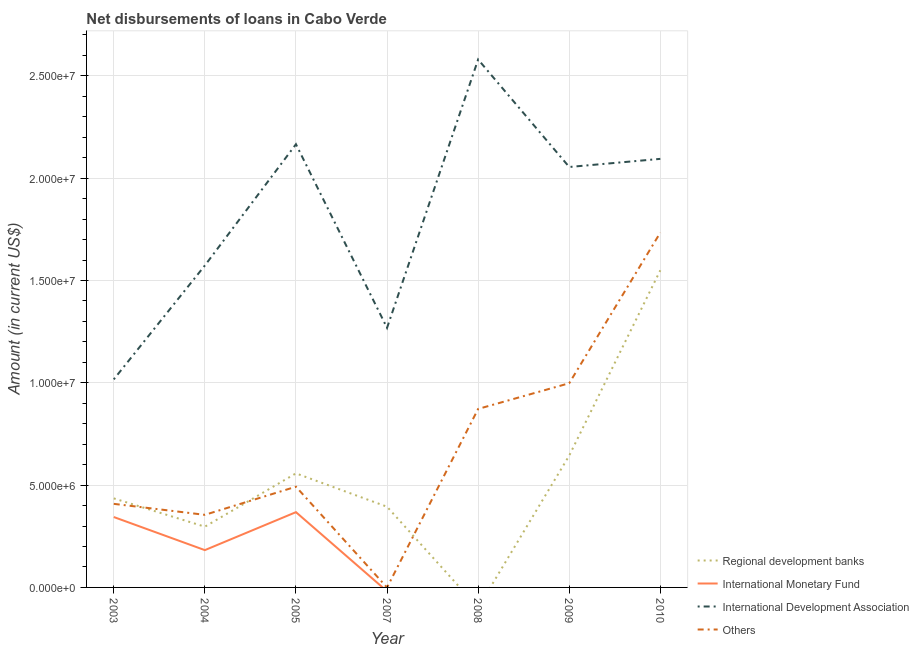How many different coloured lines are there?
Provide a short and direct response. 4. Does the line corresponding to amount of loan disimbursed by international development association intersect with the line corresponding to amount of loan disimbursed by regional development banks?
Provide a short and direct response. No. Is the number of lines equal to the number of legend labels?
Give a very brief answer. No. What is the amount of loan disimbursed by regional development banks in 2004?
Your answer should be compact. 2.97e+06. Across all years, what is the maximum amount of loan disimbursed by international development association?
Your answer should be very brief. 2.58e+07. Across all years, what is the minimum amount of loan disimbursed by international monetary fund?
Ensure brevity in your answer.  0. What is the total amount of loan disimbursed by international development association in the graph?
Offer a terse response. 1.28e+08. What is the difference between the amount of loan disimbursed by regional development banks in 2005 and that in 2007?
Make the answer very short. 1.63e+06. What is the difference between the amount of loan disimbursed by international monetary fund in 2004 and the amount of loan disimbursed by international development association in 2009?
Offer a terse response. -1.87e+07. What is the average amount of loan disimbursed by other organisations per year?
Make the answer very short. 6.94e+06. In the year 2003, what is the difference between the amount of loan disimbursed by international development association and amount of loan disimbursed by international monetary fund?
Give a very brief answer. 6.73e+06. In how many years, is the amount of loan disimbursed by international development association greater than 23000000 US$?
Make the answer very short. 1. What is the ratio of the amount of loan disimbursed by regional development banks in 2004 to that in 2005?
Make the answer very short. 0.53. Is the amount of loan disimbursed by regional development banks in 2005 less than that in 2009?
Provide a succinct answer. Yes. What is the difference between the highest and the second highest amount of loan disimbursed by regional development banks?
Your answer should be very brief. 9.06e+06. What is the difference between the highest and the lowest amount of loan disimbursed by international monetary fund?
Your response must be concise. 3.68e+06. Is the sum of the amount of loan disimbursed by regional development banks in 2004 and 2009 greater than the maximum amount of loan disimbursed by international development association across all years?
Your answer should be compact. No. Is it the case that in every year, the sum of the amount of loan disimbursed by regional development banks and amount of loan disimbursed by international monetary fund is greater than the sum of amount of loan disimbursed by international development association and amount of loan disimbursed by other organisations?
Provide a succinct answer. No. Is it the case that in every year, the sum of the amount of loan disimbursed by regional development banks and amount of loan disimbursed by international monetary fund is greater than the amount of loan disimbursed by international development association?
Offer a very short reply. No. Does the graph contain grids?
Offer a very short reply. Yes. Where does the legend appear in the graph?
Provide a succinct answer. Bottom right. How are the legend labels stacked?
Offer a very short reply. Vertical. What is the title of the graph?
Your answer should be very brief. Net disbursements of loans in Cabo Verde. What is the label or title of the X-axis?
Your response must be concise. Year. What is the Amount (in current US$) of Regional development banks in 2003?
Your answer should be very brief. 4.35e+06. What is the Amount (in current US$) of International Monetary Fund in 2003?
Your answer should be compact. 3.44e+06. What is the Amount (in current US$) of International Development Association in 2003?
Make the answer very short. 1.02e+07. What is the Amount (in current US$) in Others in 2003?
Offer a very short reply. 4.08e+06. What is the Amount (in current US$) of Regional development banks in 2004?
Provide a short and direct response. 2.97e+06. What is the Amount (in current US$) of International Monetary Fund in 2004?
Offer a very short reply. 1.82e+06. What is the Amount (in current US$) of International Development Association in 2004?
Your response must be concise. 1.57e+07. What is the Amount (in current US$) in Others in 2004?
Keep it short and to the point. 3.55e+06. What is the Amount (in current US$) of Regional development banks in 2005?
Make the answer very short. 5.58e+06. What is the Amount (in current US$) of International Monetary Fund in 2005?
Provide a short and direct response. 3.68e+06. What is the Amount (in current US$) of International Development Association in 2005?
Provide a succinct answer. 2.17e+07. What is the Amount (in current US$) in Others in 2005?
Give a very brief answer. 4.92e+06. What is the Amount (in current US$) in Regional development banks in 2007?
Give a very brief answer. 3.94e+06. What is the Amount (in current US$) in International Development Association in 2007?
Your response must be concise. 1.27e+07. What is the Amount (in current US$) in Regional development banks in 2008?
Keep it short and to the point. 0. What is the Amount (in current US$) in International Development Association in 2008?
Your response must be concise. 2.58e+07. What is the Amount (in current US$) in Others in 2008?
Keep it short and to the point. 8.72e+06. What is the Amount (in current US$) of Regional development banks in 2009?
Provide a short and direct response. 6.44e+06. What is the Amount (in current US$) of International Monetary Fund in 2009?
Give a very brief answer. 0. What is the Amount (in current US$) of International Development Association in 2009?
Ensure brevity in your answer.  2.05e+07. What is the Amount (in current US$) of Others in 2009?
Offer a very short reply. 9.98e+06. What is the Amount (in current US$) of Regional development banks in 2010?
Your answer should be compact. 1.55e+07. What is the Amount (in current US$) of International Development Association in 2010?
Offer a very short reply. 2.09e+07. What is the Amount (in current US$) of Others in 2010?
Make the answer very short. 1.73e+07. Across all years, what is the maximum Amount (in current US$) in Regional development banks?
Your answer should be very brief. 1.55e+07. Across all years, what is the maximum Amount (in current US$) in International Monetary Fund?
Provide a succinct answer. 3.68e+06. Across all years, what is the maximum Amount (in current US$) in International Development Association?
Keep it short and to the point. 2.58e+07. Across all years, what is the maximum Amount (in current US$) of Others?
Your response must be concise. 1.73e+07. Across all years, what is the minimum Amount (in current US$) of International Monetary Fund?
Provide a succinct answer. 0. Across all years, what is the minimum Amount (in current US$) in International Development Association?
Provide a succinct answer. 1.02e+07. What is the total Amount (in current US$) of Regional development banks in the graph?
Your answer should be compact. 3.88e+07. What is the total Amount (in current US$) in International Monetary Fund in the graph?
Make the answer very short. 8.94e+06. What is the total Amount (in current US$) of International Development Association in the graph?
Offer a very short reply. 1.28e+08. What is the total Amount (in current US$) in Others in the graph?
Keep it short and to the point. 4.86e+07. What is the difference between the Amount (in current US$) in Regional development banks in 2003 and that in 2004?
Give a very brief answer. 1.38e+06. What is the difference between the Amount (in current US$) of International Monetary Fund in 2003 and that in 2004?
Provide a short and direct response. 1.62e+06. What is the difference between the Amount (in current US$) of International Development Association in 2003 and that in 2004?
Your answer should be compact. -5.57e+06. What is the difference between the Amount (in current US$) of Others in 2003 and that in 2004?
Provide a succinct answer. 5.37e+05. What is the difference between the Amount (in current US$) in Regional development banks in 2003 and that in 2005?
Offer a very short reply. -1.22e+06. What is the difference between the Amount (in current US$) of International Monetary Fund in 2003 and that in 2005?
Your answer should be very brief. -2.38e+05. What is the difference between the Amount (in current US$) in International Development Association in 2003 and that in 2005?
Offer a very short reply. -1.15e+07. What is the difference between the Amount (in current US$) of Others in 2003 and that in 2005?
Provide a short and direct response. -8.38e+05. What is the difference between the Amount (in current US$) of Regional development banks in 2003 and that in 2007?
Your answer should be very brief. 4.08e+05. What is the difference between the Amount (in current US$) in International Development Association in 2003 and that in 2007?
Your answer should be compact. -2.52e+06. What is the difference between the Amount (in current US$) of International Development Association in 2003 and that in 2008?
Offer a terse response. -1.56e+07. What is the difference between the Amount (in current US$) in Others in 2003 and that in 2008?
Make the answer very short. -4.64e+06. What is the difference between the Amount (in current US$) of Regional development banks in 2003 and that in 2009?
Provide a succinct answer. -2.09e+06. What is the difference between the Amount (in current US$) of International Development Association in 2003 and that in 2009?
Offer a terse response. -1.04e+07. What is the difference between the Amount (in current US$) in Others in 2003 and that in 2009?
Your answer should be compact. -5.90e+06. What is the difference between the Amount (in current US$) in Regional development banks in 2003 and that in 2010?
Make the answer very short. -1.11e+07. What is the difference between the Amount (in current US$) of International Development Association in 2003 and that in 2010?
Your response must be concise. -1.08e+07. What is the difference between the Amount (in current US$) of Others in 2003 and that in 2010?
Give a very brief answer. -1.33e+07. What is the difference between the Amount (in current US$) of Regional development banks in 2004 and that in 2005?
Offer a very short reply. -2.61e+06. What is the difference between the Amount (in current US$) of International Monetary Fund in 2004 and that in 2005?
Your answer should be very brief. -1.86e+06. What is the difference between the Amount (in current US$) of International Development Association in 2004 and that in 2005?
Keep it short and to the point. -5.93e+06. What is the difference between the Amount (in current US$) in Others in 2004 and that in 2005?
Your answer should be very brief. -1.38e+06. What is the difference between the Amount (in current US$) in Regional development banks in 2004 and that in 2007?
Give a very brief answer. -9.76e+05. What is the difference between the Amount (in current US$) in International Development Association in 2004 and that in 2007?
Provide a succinct answer. 3.05e+06. What is the difference between the Amount (in current US$) in International Development Association in 2004 and that in 2008?
Give a very brief answer. -1.01e+07. What is the difference between the Amount (in current US$) in Others in 2004 and that in 2008?
Ensure brevity in your answer.  -5.18e+06. What is the difference between the Amount (in current US$) of Regional development banks in 2004 and that in 2009?
Provide a short and direct response. -3.48e+06. What is the difference between the Amount (in current US$) in International Development Association in 2004 and that in 2009?
Provide a succinct answer. -4.82e+06. What is the difference between the Amount (in current US$) in Others in 2004 and that in 2009?
Your response must be concise. -6.43e+06. What is the difference between the Amount (in current US$) of Regional development banks in 2004 and that in 2010?
Keep it short and to the point. -1.25e+07. What is the difference between the Amount (in current US$) in International Development Association in 2004 and that in 2010?
Your response must be concise. -5.21e+06. What is the difference between the Amount (in current US$) in Others in 2004 and that in 2010?
Offer a very short reply. -1.38e+07. What is the difference between the Amount (in current US$) of Regional development banks in 2005 and that in 2007?
Ensure brevity in your answer.  1.63e+06. What is the difference between the Amount (in current US$) in International Development Association in 2005 and that in 2007?
Your answer should be very brief. 8.97e+06. What is the difference between the Amount (in current US$) of International Development Association in 2005 and that in 2008?
Your answer should be very brief. -4.14e+06. What is the difference between the Amount (in current US$) in Others in 2005 and that in 2008?
Your answer should be compact. -3.80e+06. What is the difference between the Amount (in current US$) of Regional development banks in 2005 and that in 2009?
Your answer should be compact. -8.69e+05. What is the difference between the Amount (in current US$) in International Development Association in 2005 and that in 2009?
Ensure brevity in your answer.  1.11e+06. What is the difference between the Amount (in current US$) of Others in 2005 and that in 2009?
Keep it short and to the point. -5.06e+06. What is the difference between the Amount (in current US$) in Regional development banks in 2005 and that in 2010?
Your answer should be very brief. -9.93e+06. What is the difference between the Amount (in current US$) in International Development Association in 2005 and that in 2010?
Provide a short and direct response. 7.15e+05. What is the difference between the Amount (in current US$) of Others in 2005 and that in 2010?
Make the answer very short. -1.24e+07. What is the difference between the Amount (in current US$) of International Development Association in 2007 and that in 2008?
Give a very brief answer. -1.31e+07. What is the difference between the Amount (in current US$) of Regional development banks in 2007 and that in 2009?
Provide a short and direct response. -2.50e+06. What is the difference between the Amount (in current US$) of International Development Association in 2007 and that in 2009?
Keep it short and to the point. -7.86e+06. What is the difference between the Amount (in current US$) of Regional development banks in 2007 and that in 2010?
Provide a short and direct response. -1.16e+07. What is the difference between the Amount (in current US$) in International Development Association in 2007 and that in 2010?
Your answer should be very brief. -8.26e+06. What is the difference between the Amount (in current US$) in International Development Association in 2008 and that in 2009?
Ensure brevity in your answer.  5.25e+06. What is the difference between the Amount (in current US$) of Others in 2008 and that in 2009?
Offer a terse response. -1.26e+06. What is the difference between the Amount (in current US$) in International Development Association in 2008 and that in 2010?
Ensure brevity in your answer.  4.86e+06. What is the difference between the Amount (in current US$) of Others in 2008 and that in 2010?
Offer a very short reply. -8.62e+06. What is the difference between the Amount (in current US$) in Regional development banks in 2009 and that in 2010?
Keep it short and to the point. -9.06e+06. What is the difference between the Amount (in current US$) in International Development Association in 2009 and that in 2010?
Give a very brief answer. -3.97e+05. What is the difference between the Amount (in current US$) in Others in 2009 and that in 2010?
Offer a terse response. -7.36e+06. What is the difference between the Amount (in current US$) of Regional development banks in 2003 and the Amount (in current US$) of International Monetary Fund in 2004?
Your response must be concise. 2.53e+06. What is the difference between the Amount (in current US$) in Regional development banks in 2003 and the Amount (in current US$) in International Development Association in 2004?
Your response must be concise. -1.14e+07. What is the difference between the Amount (in current US$) of Regional development banks in 2003 and the Amount (in current US$) of Others in 2004?
Ensure brevity in your answer.  8.04e+05. What is the difference between the Amount (in current US$) in International Monetary Fund in 2003 and the Amount (in current US$) in International Development Association in 2004?
Provide a short and direct response. -1.23e+07. What is the difference between the Amount (in current US$) of International Monetary Fund in 2003 and the Amount (in current US$) of Others in 2004?
Keep it short and to the point. -1.07e+05. What is the difference between the Amount (in current US$) of International Development Association in 2003 and the Amount (in current US$) of Others in 2004?
Your response must be concise. 6.62e+06. What is the difference between the Amount (in current US$) of Regional development banks in 2003 and the Amount (in current US$) of International Monetary Fund in 2005?
Your response must be concise. 6.73e+05. What is the difference between the Amount (in current US$) in Regional development banks in 2003 and the Amount (in current US$) in International Development Association in 2005?
Ensure brevity in your answer.  -1.73e+07. What is the difference between the Amount (in current US$) in Regional development banks in 2003 and the Amount (in current US$) in Others in 2005?
Your answer should be very brief. -5.71e+05. What is the difference between the Amount (in current US$) of International Monetary Fund in 2003 and the Amount (in current US$) of International Development Association in 2005?
Your answer should be compact. -1.82e+07. What is the difference between the Amount (in current US$) in International Monetary Fund in 2003 and the Amount (in current US$) in Others in 2005?
Your response must be concise. -1.48e+06. What is the difference between the Amount (in current US$) of International Development Association in 2003 and the Amount (in current US$) of Others in 2005?
Provide a succinct answer. 5.24e+06. What is the difference between the Amount (in current US$) of Regional development banks in 2003 and the Amount (in current US$) of International Development Association in 2007?
Provide a short and direct response. -8.34e+06. What is the difference between the Amount (in current US$) of International Monetary Fund in 2003 and the Amount (in current US$) of International Development Association in 2007?
Offer a very short reply. -9.25e+06. What is the difference between the Amount (in current US$) in Regional development banks in 2003 and the Amount (in current US$) in International Development Association in 2008?
Offer a terse response. -2.14e+07. What is the difference between the Amount (in current US$) in Regional development banks in 2003 and the Amount (in current US$) in Others in 2008?
Offer a very short reply. -4.37e+06. What is the difference between the Amount (in current US$) in International Monetary Fund in 2003 and the Amount (in current US$) in International Development Association in 2008?
Your answer should be compact. -2.24e+07. What is the difference between the Amount (in current US$) in International Monetary Fund in 2003 and the Amount (in current US$) in Others in 2008?
Keep it short and to the point. -5.28e+06. What is the difference between the Amount (in current US$) in International Development Association in 2003 and the Amount (in current US$) in Others in 2008?
Give a very brief answer. 1.44e+06. What is the difference between the Amount (in current US$) in Regional development banks in 2003 and the Amount (in current US$) in International Development Association in 2009?
Make the answer very short. -1.62e+07. What is the difference between the Amount (in current US$) of Regional development banks in 2003 and the Amount (in current US$) of Others in 2009?
Your response must be concise. -5.63e+06. What is the difference between the Amount (in current US$) of International Monetary Fund in 2003 and the Amount (in current US$) of International Development Association in 2009?
Provide a short and direct response. -1.71e+07. What is the difference between the Amount (in current US$) in International Monetary Fund in 2003 and the Amount (in current US$) in Others in 2009?
Make the answer very short. -6.54e+06. What is the difference between the Amount (in current US$) of International Development Association in 2003 and the Amount (in current US$) of Others in 2009?
Offer a very short reply. 1.88e+05. What is the difference between the Amount (in current US$) in Regional development banks in 2003 and the Amount (in current US$) in International Development Association in 2010?
Your answer should be compact. -1.66e+07. What is the difference between the Amount (in current US$) of Regional development banks in 2003 and the Amount (in current US$) of Others in 2010?
Your answer should be compact. -1.30e+07. What is the difference between the Amount (in current US$) of International Monetary Fund in 2003 and the Amount (in current US$) of International Development Association in 2010?
Your answer should be compact. -1.75e+07. What is the difference between the Amount (in current US$) of International Monetary Fund in 2003 and the Amount (in current US$) of Others in 2010?
Your answer should be compact. -1.39e+07. What is the difference between the Amount (in current US$) in International Development Association in 2003 and the Amount (in current US$) in Others in 2010?
Ensure brevity in your answer.  -7.18e+06. What is the difference between the Amount (in current US$) of Regional development banks in 2004 and the Amount (in current US$) of International Monetary Fund in 2005?
Provide a short and direct response. -7.11e+05. What is the difference between the Amount (in current US$) in Regional development banks in 2004 and the Amount (in current US$) in International Development Association in 2005?
Keep it short and to the point. -1.87e+07. What is the difference between the Amount (in current US$) of Regional development banks in 2004 and the Amount (in current US$) of Others in 2005?
Keep it short and to the point. -1.96e+06. What is the difference between the Amount (in current US$) in International Monetary Fund in 2004 and the Amount (in current US$) in International Development Association in 2005?
Your response must be concise. -1.98e+07. What is the difference between the Amount (in current US$) of International Monetary Fund in 2004 and the Amount (in current US$) of Others in 2005?
Keep it short and to the point. -3.10e+06. What is the difference between the Amount (in current US$) in International Development Association in 2004 and the Amount (in current US$) in Others in 2005?
Ensure brevity in your answer.  1.08e+07. What is the difference between the Amount (in current US$) in Regional development banks in 2004 and the Amount (in current US$) in International Development Association in 2007?
Make the answer very short. -9.72e+06. What is the difference between the Amount (in current US$) of International Monetary Fund in 2004 and the Amount (in current US$) of International Development Association in 2007?
Keep it short and to the point. -1.09e+07. What is the difference between the Amount (in current US$) in Regional development banks in 2004 and the Amount (in current US$) in International Development Association in 2008?
Give a very brief answer. -2.28e+07. What is the difference between the Amount (in current US$) in Regional development banks in 2004 and the Amount (in current US$) in Others in 2008?
Your answer should be very brief. -5.76e+06. What is the difference between the Amount (in current US$) in International Monetary Fund in 2004 and the Amount (in current US$) in International Development Association in 2008?
Give a very brief answer. -2.40e+07. What is the difference between the Amount (in current US$) in International Monetary Fund in 2004 and the Amount (in current US$) in Others in 2008?
Ensure brevity in your answer.  -6.90e+06. What is the difference between the Amount (in current US$) in International Development Association in 2004 and the Amount (in current US$) in Others in 2008?
Keep it short and to the point. 7.01e+06. What is the difference between the Amount (in current US$) of Regional development banks in 2004 and the Amount (in current US$) of International Development Association in 2009?
Provide a succinct answer. -1.76e+07. What is the difference between the Amount (in current US$) of Regional development banks in 2004 and the Amount (in current US$) of Others in 2009?
Offer a terse response. -7.01e+06. What is the difference between the Amount (in current US$) in International Monetary Fund in 2004 and the Amount (in current US$) in International Development Association in 2009?
Your answer should be very brief. -1.87e+07. What is the difference between the Amount (in current US$) in International Monetary Fund in 2004 and the Amount (in current US$) in Others in 2009?
Your answer should be compact. -8.16e+06. What is the difference between the Amount (in current US$) of International Development Association in 2004 and the Amount (in current US$) of Others in 2009?
Ensure brevity in your answer.  5.75e+06. What is the difference between the Amount (in current US$) of Regional development banks in 2004 and the Amount (in current US$) of International Development Association in 2010?
Your answer should be compact. -1.80e+07. What is the difference between the Amount (in current US$) in Regional development banks in 2004 and the Amount (in current US$) in Others in 2010?
Make the answer very short. -1.44e+07. What is the difference between the Amount (in current US$) of International Monetary Fund in 2004 and the Amount (in current US$) of International Development Association in 2010?
Your response must be concise. -1.91e+07. What is the difference between the Amount (in current US$) in International Monetary Fund in 2004 and the Amount (in current US$) in Others in 2010?
Keep it short and to the point. -1.55e+07. What is the difference between the Amount (in current US$) of International Development Association in 2004 and the Amount (in current US$) of Others in 2010?
Provide a short and direct response. -1.61e+06. What is the difference between the Amount (in current US$) in Regional development banks in 2005 and the Amount (in current US$) in International Development Association in 2007?
Keep it short and to the point. -7.11e+06. What is the difference between the Amount (in current US$) in International Monetary Fund in 2005 and the Amount (in current US$) in International Development Association in 2007?
Your answer should be compact. -9.01e+06. What is the difference between the Amount (in current US$) of Regional development banks in 2005 and the Amount (in current US$) of International Development Association in 2008?
Your answer should be compact. -2.02e+07. What is the difference between the Amount (in current US$) of Regional development banks in 2005 and the Amount (in current US$) of Others in 2008?
Provide a succinct answer. -3.15e+06. What is the difference between the Amount (in current US$) of International Monetary Fund in 2005 and the Amount (in current US$) of International Development Association in 2008?
Provide a short and direct response. -2.21e+07. What is the difference between the Amount (in current US$) of International Monetary Fund in 2005 and the Amount (in current US$) of Others in 2008?
Provide a short and direct response. -5.04e+06. What is the difference between the Amount (in current US$) in International Development Association in 2005 and the Amount (in current US$) in Others in 2008?
Give a very brief answer. 1.29e+07. What is the difference between the Amount (in current US$) of Regional development banks in 2005 and the Amount (in current US$) of International Development Association in 2009?
Provide a succinct answer. -1.50e+07. What is the difference between the Amount (in current US$) in Regional development banks in 2005 and the Amount (in current US$) in Others in 2009?
Your response must be concise. -4.40e+06. What is the difference between the Amount (in current US$) of International Monetary Fund in 2005 and the Amount (in current US$) of International Development Association in 2009?
Make the answer very short. -1.69e+07. What is the difference between the Amount (in current US$) of International Monetary Fund in 2005 and the Amount (in current US$) of Others in 2009?
Ensure brevity in your answer.  -6.30e+06. What is the difference between the Amount (in current US$) in International Development Association in 2005 and the Amount (in current US$) in Others in 2009?
Your answer should be compact. 1.17e+07. What is the difference between the Amount (in current US$) in Regional development banks in 2005 and the Amount (in current US$) in International Development Association in 2010?
Keep it short and to the point. -1.54e+07. What is the difference between the Amount (in current US$) of Regional development banks in 2005 and the Amount (in current US$) of Others in 2010?
Make the answer very short. -1.18e+07. What is the difference between the Amount (in current US$) in International Monetary Fund in 2005 and the Amount (in current US$) in International Development Association in 2010?
Provide a short and direct response. -1.73e+07. What is the difference between the Amount (in current US$) of International Monetary Fund in 2005 and the Amount (in current US$) of Others in 2010?
Offer a very short reply. -1.37e+07. What is the difference between the Amount (in current US$) in International Development Association in 2005 and the Amount (in current US$) in Others in 2010?
Your answer should be very brief. 4.32e+06. What is the difference between the Amount (in current US$) of Regional development banks in 2007 and the Amount (in current US$) of International Development Association in 2008?
Offer a terse response. -2.19e+07. What is the difference between the Amount (in current US$) of Regional development banks in 2007 and the Amount (in current US$) of Others in 2008?
Your response must be concise. -4.78e+06. What is the difference between the Amount (in current US$) of International Development Association in 2007 and the Amount (in current US$) of Others in 2008?
Offer a terse response. 3.96e+06. What is the difference between the Amount (in current US$) of Regional development banks in 2007 and the Amount (in current US$) of International Development Association in 2009?
Provide a short and direct response. -1.66e+07. What is the difference between the Amount (in current US$) in Regional development banks in 2007 and the Amount (in current US$) in Others in 2009?
Provide a succinct answer. -6.04e+06. What is the difference between the Amount (in current US$) in International Development Association in 2007 and the Amount (in current US$) in Others in 2009?
Your answer should be very brief. 2.71e+06. What is the difference between the Amount (in current US$) of Regional development banks in 2007 and the Amount (in current US$) of International Development Association in 2010?
Offer a very short reply. -1.70e+07. What is the difference between the Amount (in current US$) of Regional development banks in 2007 and the Amount (in current US$) of Others in 2010?
Offer a very short reply. -1.34e+07. What is the difference between the Amount (in current US$) in International Development Association in 2007 and the Amount (in current US$) in Others in 2010?
Keep it short and to the point. -4.66e+06. What is the difference between the Amount (in current US$) of International Development Association in 2008 and the Amount (in current US$) of Others in 2009?
Ensure brevity in your answer.  1.58e+07. What is the difference between the Amount (in current US$) in International Development Association in 2008 and the Amount (in current US$) in Others in 2010?
Offer a very short reply. 8.46e+06. What is the difference between the Amount (in current US$) of Regional development banks in 2009 and the Amount (in current US$) of International Development Association in 2010?
Your response must be concise. -1.45e+07. What is the difference between the Amount (in current US$) of Regional development banks in 2009 and the Amount (in current US$) of Others in 2010?
Provide a succinct answer. -1.09e+07. What is the difference between the Amount (in current US$) of International Development Association in 2009 and the Amount (in current US$) of Others in 2010?
Offer a terse response. 3.21e+06. What is the average Amount (in current US$) in Regional development banks per year?
Keep it short and to the point. 5.54e+06. What is the average Amount (in current US$) of International Monetary Fund per year?
Give a very brief answer. 1.28e+06. What is the average Amount (in current US$) of International Development Association per year?
Your answer should be very brief. 1.82e+07. What is the average Amount (in current US$) of Others per year?
Provide a short and direct response. 6.94e+06. In the year 2003, what is the difference between the Amount (in current US$) of Regional development banks and Amount (in current US$) of International Monetary Fund?
Make the answer very short. 9.11e+05. In the year 2003, what is the difference between the Amount (in current US$) in Regional development banks and Amount (in current US$) in International Development Association?
Your answer should be very brief. -5.82e+06. In the year 2003, what is the difference between the Amount (in current US$) of Regional development banks and Amount (in current US$) of Others?
Keep it short and to the point. 2.67e+05. In the year 2003, what is the difference between the Amount (in current US$) of International Monetary Fund and Amount (in current US$) of International Development Association?
Make the answer very short. -6.73e+06. In the year 2003, what is the difference between the Amount (in current US$) of International Monetary Fund and Amount (in current US$) of Others?
Ensure brevity in your answer.  -6.44e+05. In the year 2003, what is the difference between the Amount (in current US$) of International Development Association and Amount (in current US$) of Others?
Offer a very short reply. 6.08e+06. In the year 2004, what is the difference between the Amount (in current US$) of Regional development banks and Amount (in current US$) of International Monetary Fund?
Keep it short and to the point. 1.14e+06. In the year 2004, what is the difference between the Amount (in current US$) in Regional development banks and Amount (in current US$) in International Development Association?
Provide a succinct answer. -1.28e+07. In the year 2004, what is the difference between the Amount (in current US$) in Regional development banks and Amount (in current US$) in Others?
Your response must be concise. -5.80e+05. In the year 2004, what is the difference between the Amount (in current US$) of International Monetary Fund and Amount (in current US$) of International Development Association?
Ensure brevity in your answer.  -1.39e+07. In the year 2004, what is the difference between the Amount (in current US$) in International Monetary Fund and Amount (in current US$) in Others?
Offer a terse response. -1.72e+06. In the year 2004, what is the difference between the Amount (in current US$) in International Development Association and Amount (in current US$) in Others?
Your answer should be very brief. 1.22e+07. In the year 2005, what is the difference between the Amount (in current US$) in Regional development banks and Amount (in current US$) in International Monetary Fund?
Your response must be concise. 1.90e+06. In the year 2005, what is the difference between the Amount (in current US$) in Regional development banks and Amount (in current US$) in International Development Association?
Offer a terse response. -1.61e+07. In the year 2005, what is the difference between the Amount (in current US$) of Regional development banks and Amount (in current US$) of Others?
Give a very brief answer. 6.52e+05. In the year 2005, what is the difference between the Amount (in current US$) in International Monetary Fund and Amount (in current US$) in International Development Association?
Offer a terse response. -1.80e+07. In the year 2005, what is the difference between the Amount (in current US$) of International Monetary Fund and Amount (in current US$) of Others?
Your response must be concise. -1.24e+06. In the year 2005, what is the difference between the Amount (in current US$) in International Development Association and Amount (in current US$) in Others?
Offer a terse response. 1.67e+07. In the year 2007, what is the difference between the Amount (in current US$) in Regional development banks and Amount (in current US$) in International Development Association?
Ensure brevity in your answer.  -8.74e+06. In the year 2008, what is the difference between the Amount (in current US$) of International Development Association and Amount (in current US$) of Others?
Ensure brevity in your answer.  1.71e+07. In the year 2009, what is the difference between the Amount (in current US$) in Regional development banks and Amount (in current US$) in International Development Association?
Give a very brief answer. -1.41e+07. In the year 2009, what is the difference between the Amount (in current US$) in Regional development banks and Amount (in current US$) in Others?
Offer a terse response. -3.54e+06. In the year 2009, what is the difference between the Amount (in current US$) of International Development Association and Amount (in current US$) of Others?
Provide a succinct answer. 1.06e+07. In the year 2010, what is the difference between the Amount (in current US$) in Regional development banks and Amount (in current US$) in International Development Association?
Offer a very short reply. -5.44e+06. In the year 2010, what is the difference between the Amount (in current US$) in Regional development banks and Amount (in current US$) in Others?
Your response must be concise. -1.84e+06. In the year 2010, what is the difference between the Amount (in current US$) of International Development Association and Amount (in current US$) of Others?
Make the answer very short. 3.60e+06. What is the ratio of the Amount (in current US$) in Regional development banks in 2003 to that in 2004?
Give a very brief answer. 1.47. What is the ratio of the Amount (in current US$) of International Monetary Fund in 2003 to that in 2004?
Keep it short and to the point. 1.89. What is the ratio of the Amount (in current US$) in International Development Association in 2003 to that in 2004?
Ensure brevity in your answer.  0.65. What is the ratio of the Amount (in current US$) of Others in 2003 to that in 2004?
Provide a succinct answer. 1.15. What is the ratio of the Amount (in current US$) in Regional development banks in 2003 to that in 2005?
Give a very brief answer. 0.78. What is the ratio of the Amount (in current US$) in International Monetary Fund in 2003 to that in 2005?
Ensure brevity in your answer.  0.94. What is the ratio of the Amount (in current US$) of International Development Association in 2003 to that in 2005?
Offer a very short reply. 0.47. What is the ratio of the Amount (in current US$) of Others in 2003 to that in 2005?
Make the answer very short. 0.83. What is the ratio of the Amount (in current US$) of Regional development banks in 2003 to that in 2007?
Offer a terse response. 1.1. What is the ratio of the Amount (in current US$) of International Development Association in 2003 to that in 2007?
Offer a very short reply. 0.8. What is the ratio of the Amount (in current US$) in International Development Association in 2003 to that in 2008?
Your response must be concise. 0.39. What is the ratio of the Amount (in current US$) of Others in 2003 to that in 2008?
Your answer should be very brief. 0.47. What is the ratio of the Amount (in current US$) in Regional development banks in 2003 to that in 2009?
Provide a short and direct response. 0.68. What is the ratio of the Amount (in current US$) in International Development Association in 2003 to that in 2009?
Ensure brevity in your answer.  0.49. What is the ratio of the Amount (in current US$) in Others in 2003 to that in 2009?
Your answer should be compact. 0.41. What is the ratio of the Amount (in current US$) of Regional development banks in 2003 to that in 2010?
Give a very brief answer. 0.28. What is the ratio of the Amount (in current US$) in International Development Association in 2003 to that in 2010?
Your answer should be very brief. 0.49. What is the ratio of the Amount (in current US$) in Others in 2003 to that in 2010?
Provide a short and direct response. 0.24. What is the ratio of the Amount (in current US$) in Regional development banks in 2004 to that in 2005?
Keep it short and to the point. 0.53. What is the ratio of the Amount (in current US$) of International Monetary Fund in 2004 to that in 2005?
Your answer should be very brief. 0.5. What is the ratio of the Amount (in current US$) of International Development Association in 2004 to that in 2005?
Provide a succinct answer. 0.73. What is the ratio of the Amount (in current US$) in Others in 2004 to that in 2005?
Your answer should be compact. 0.72. What is the ratio of the Amount (in current US$) in Regional development banks in 2004 to that in 2007?
Give a very brief answer. 0.75. What is the ratio of the Amount (in current US$) of International Development Association in 2004 to that in 2007?
Offer a very short reply. 1.24. What is the ratio of the Amount (in current US$) in International Development Association in 2004 to that in 2008?
Your answer should be compact. 0.61. What is the ratio of the Amount (in current US$) of Others in 2004 to that in 2008?
Give a very brief answer. 0.41. What is the ratio of the Amount (in current US$) of Regional development banks in 2004 to that in 2009?
Your answer should be very brief. 0.46. What is the ratio of the Amount (in current US$) in International Development Association in 2004 to that in 2009?
Provide a succinct answer. 0.77. What is the ratio of the Amount (in current US$) of Others in 2004 to that in 2009?
Provide a short and direct response. 0.36. What is the ratio of the Amount (in current US$) in Regional development banks in 2004 to that in 2010?
Your answer should be very brief. 0.19. What is the ratio of the Amount (in current US$) in International Development Association in 2004 to that in 2010?
Provide a short and direct response. 0.75. What is the ratio of the Amount (in current US$) in Others in 2004 to that in 2010?
Provide a succinct answer. 0.2. What is the ratio of the Amount (in current US$) of Regional development banks in 2005 to that in 2007?
Keep it short and to the point. 1.41. What is the ratio of the Amount (in current US$) in International Development Association in 2005 to that in 2007?
Your answer should be compact. 1.71. What is the ratio of the Amount (in current US$) of International Development Association in 2005 to that in 2008?
Offer a very short reply. 0.84. What is the ratio of the Amount (in current US$) of Others in 2005 to that in 2008?
Offer a very short reply. 0.56. What is the ratio of the Amount (in current US$) in Regional development banks in 2005 to that in 2009?
Your response must be concise. 0.87. What is the ratio of the Amount (in current US$) of International Development Association in 2005 to that in 2009?
Offer a terse response. 1.05. What is the ratio of the Amount (in current US$) of Others in 2005 to that in 2009?
Your answer should be compact. 0.49. What is the ratio of the Amount (in current US$) of Regional development banks in 2005 to that in 2010?
Keep it short and to the point. 0.36. What is the ratio of the Amount (in current US$) of International Development Association in 2005 to that in 2010?
Keep it short and to the point. 1.03. What is the ratio of the Amount (in current US$) of Others in 2005 to that in 2010?
Give a very brief answer. 0.28. What is the ratio of the Amount (in current US$) of International Development Association in 2007 to that in 2008?
Ensure brevity in your answer.  0.49. What is the ratio of the Amount (in current US$) of Regional development banks in 2007 to that in 2009?
Your answer should be very brief. 0.61. What is the ratio of the Amount (in current US$) of International Development Association in 2007 to that in 2009?
Offer a terse response. 0.62. What is the ratio of the Amount (in current US$) of Regional development banks in 2007 to that in 2010?
Your answer should be compact. 0.25. What is the ratio of the Amount (in current US$) of International Development Association in 2007 to that in 2010?
Offer a terse response. 0.61. What is the ratio of the Amount (in current US$) in International Development Association in 2008 to that in 2009?
Give a very brief answer. 1.26. What is the ratio of the Amount (in current US$) in Others in 2008 to that in 2009?
Make the answer very short. 0.87. What is the ratio of the Amount (in current US$) of International Development Association in 2008 to that in 2010?
Your response must be concise. 1.23. What is the ratio of the Amount (in current US$) of Others in 2008 to that in 2010?
Offer a terse response. 0.5. What is the ratio of the Amount (in current US$) in Regional development banks in 2009 to that in 2010?
Give a very brief answer. 0.42. What is the ratio of the Amount (in current US$) of International Development Association in 2009 to that in 2010?
Ensure brevity in your answer.  0.98. What is the ratio of the Amount (in current US$) in Others in 2009 to that in 2010?
Provide a succinct answer. 0.58. What is the difference between the highest and the second highest Amount (in current US$) of Regional development banks?
Provide a short and direct response. 9.06e+06. What is the difference between the highest and the second highest Amount (in current US$) of International Monetary Fund?
Offer a very short reply. 2.38e+05. What is the difference between the highest and the second highest Amount (in current US$) of International Development Association?
Make the answer very short. 4.14e+06. What is the difference between the highest and the second highest Amount (in current US$) of Others?
Make the answer very short. 7.36e+06. What is the difference between the highest and the lowest Amount (in current US$) of Regional development banks?
Keep it short and to the point. 1.55e+07. What is the difference between the highest and the lowest Amount (in current US$) in International Monetary Fund?
Provide a succinct answer. 3.68e+06. What is the difference between the highest and the lowest Amount (in current US$) of International Development Association?
Your response must be concise. 1.56e+07. What is the difference between the highest and the lowest Amount (in current US$) in Others?
Offer a very short reply. 1.73e+07. 